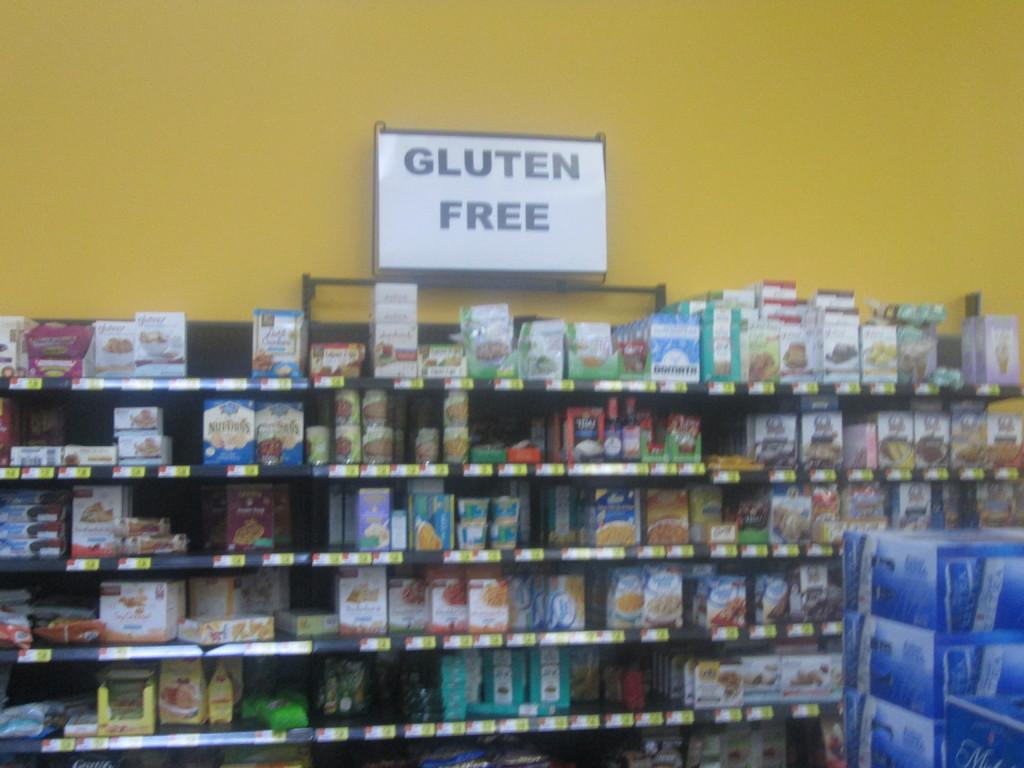What section of store is this?
Your answer should be very brief. Gluten free. What is free?
Offer a very short reply. Gluten. 